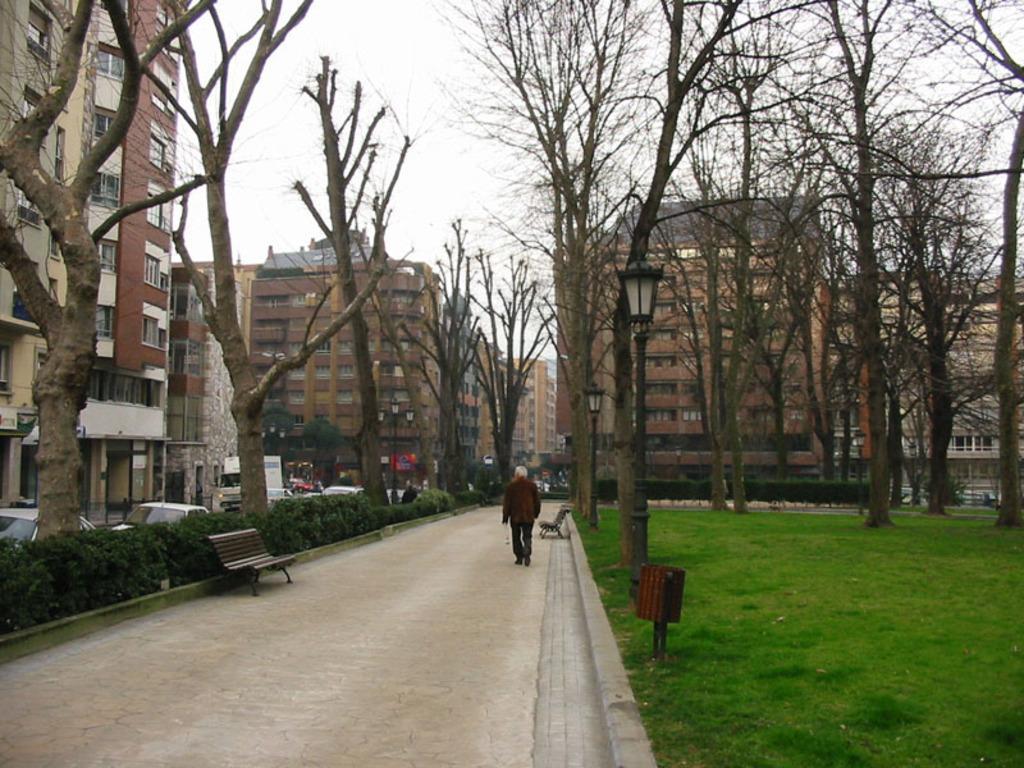Could you give a brief overview of what you see in this image? In this picture I can see trees and buildings. On the right side I can see grass and some object on the ground. On the left side I can see road, benches, a person is standing, vehicles and sky. 